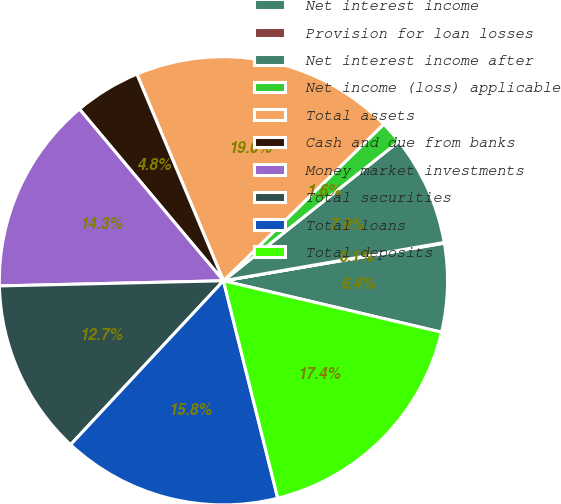Convert chart to OTSL. <chart><loc_0><loc_0><loc_500><loc_500><pie_chart><fcel>Net interest income<fcel>Provision for loan losses<fcel>Net interest income after<fcel>Net income (loss) applicable<fcel>Total assets<fcel>Cash and due from banks<fcel>Money market investments<fcel>Total securities<fcel>Total loans<fcel>Total deposits<nl><fcel>6.37%<fcel>0.05%<fcel>7.95%<fcel>1.63%<fcel>19.0%<fcel>4.79%<fcel>14.26%<fcel>12.69%<fcel>15.84%<fcel>17.42%<nl></chart> 